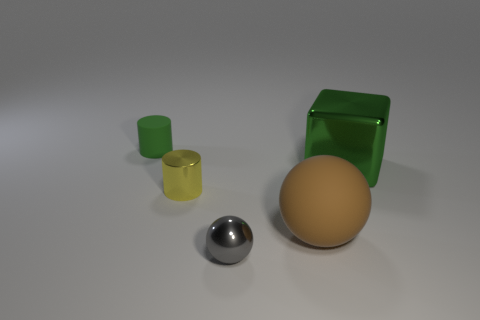Subtract 1 brown balls. How many objects are left? 4 Subtract all cylinders. How many objects are left? 3 Subtract 1 cylinders. How many cylinders are left? 1 Subtract all red cubes. Subtract all blue balls. How many cubes are left? 1 Subtract all yellow cylinders. How many brown balls are left? 1 Subtract all big yellow metal blocks. Subtract all small green objects. How many objects are left? 4 Add 4 big things. How many big things are left? 6 Add 2 large green things. How many large green things exist? 3 Add 4 green shiny blocks. How many objects exist? 9 